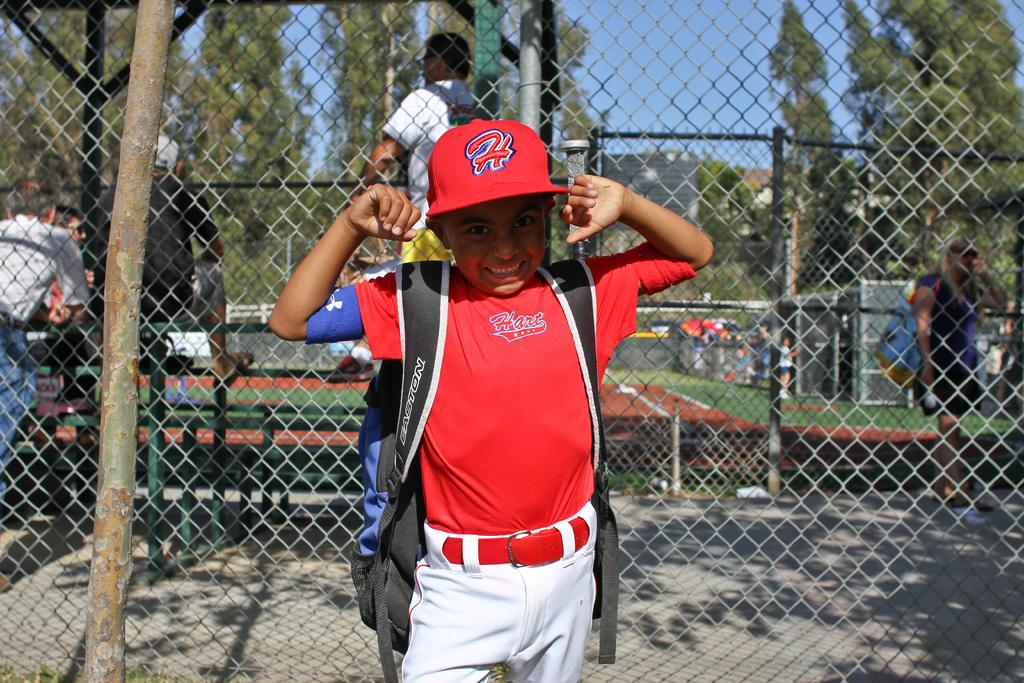<image>
Share a concise interpretation of the image provided. A boy with an H on his baseball hat flexes his arms. 